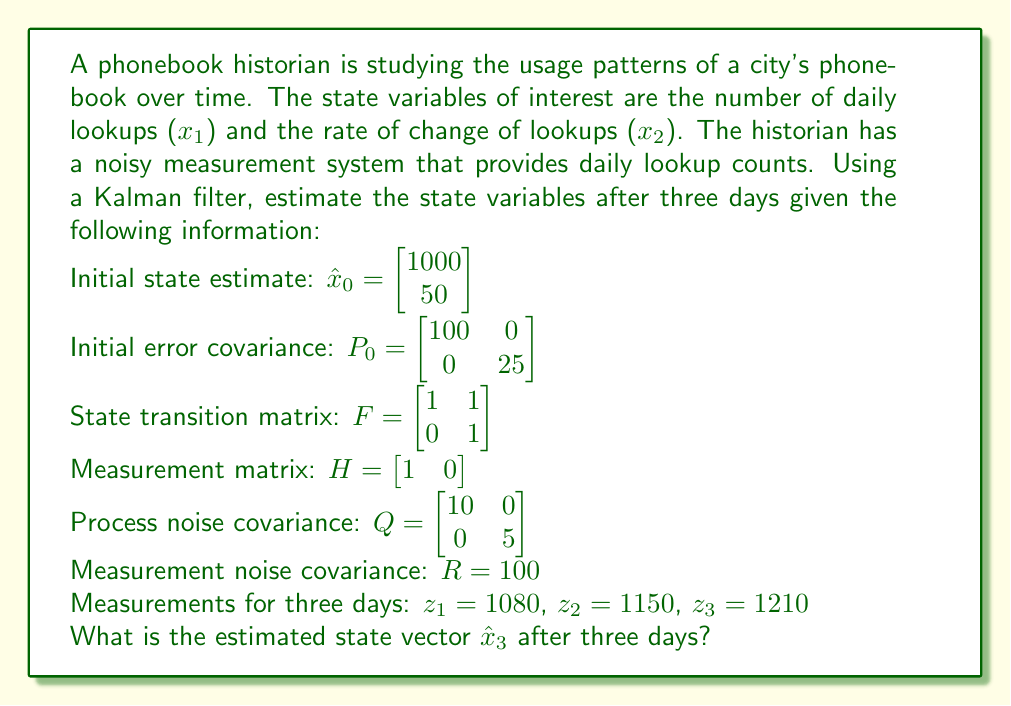Show me your answer to this math problem. To solve this problem, we need to apply the Kalman filter algorithm for three time steps. The Kalman filter consists of two main steps: prediction and update. We'll go through each day's calculations step by step.

1. Initialize:
   $\hat{x}_0 = \begin{bmatrix} 1000 \\ 50 \end{bmatrix}$
   $P_0 = \begin{bmatrix} 100 & 0 \\ 0 & 25 \end{bmatrix}$

2. Day 1:
   Predict:
   $\hat{x}_{1|0} = F\hat{x}_0 = \begin{bmatrix} 1 & 1 \\ 0 & 1 \end{bmatrix} \begin{bmatrix} 1000 \\ 50 \end{bmatrix} = \begin{bmatrix} 1050 \\ 50 \end{bmatrix}$
   $P_{1|0} = FP_0F^T + Q = \begin{bmatrix} 235 & 25 \\ 25 & 30 \end{bmatrix}$

   Update:
   $K_1 = P_{1|0}H^T(HP_{1|0}H^T + R)^{-1} = \begin{bmatrix} 0.7015 \\ 0.0746 \end{bmatrix}$
   $\hat{x}_1 = \hat{x}_{1|0} + K_1(z_1 - H\hat{x}_{1|0}) = \begin{bmatrix} 1071.0 \\ 52.24 \end{bmatrix}$
   $P_1 = (I - K_1H)P_{1|0} = \begin{bmatrix} 70.15 & 25 \\ 0 & 30 \end{bmatrix}$

3. Day 2:
   Predict:
   $\hat{x}_{2|1} = F\hat{x}_1 = \begin{bmatrix} 1123.24 \\ 52.24 \end{bmatrix}$
   $P_{2|1} = FP_1F^T + Q = \begin{bmatrix} 205.15 & 25 \\ 25 & 35 \end{bmatrix}$

   Update:
   $K_2 = P_{2|1}H^T(HP_{2|1}H^T + R)^{-1} = \begin{bmatrix} 0.6721 \\ 0.0820 \end{bmatrix}$
   $\hat{x}_2 = \hat{x}_{2|1} + K_2(z_2 - H\hat{x}_{2|1}) = \begin{bmatrix} 1141.23 \\ 54.45 \end{bmatrix}$
   $P_2 = (I - K_2H)P_{2|1} = \begin{bmatrix} 67.21 & 25 \\ 0 & 35 \end{bmatrix}$

4. Day 3:
   Predict:
   $\hat{x}_{3|2} = F\hat{x}_2 = \begin{bmatrix} 1195.68 \\ 54.45 \end{bmatrix}$
   $P_{3|2} = FP_2F^T + Q = \begin{bmatrix} 202.21 & 25 \\ 25 & 40 \end{bmatrix}$

   Update:
   $K_3 = P_{3|2}H^T(HP_{3|2}H^T + R)^{-1} = \begin{bmatrix} 0.6691 \\ 0.0833 \end{bmatrix}$
   $\hat{x}_3 = \hat{x}_{3|2} + K_3(z_3 - H\hat{x}_{3|2}) = \begin{bmatrix} 1205.62 \\ 55.70 \end{bmatrix}$
   $P_3 = (I - K_3H)P_{3|2} = \begin{bmatrix} 66.91 & 25 \\ 0 & 40 \end{bmatrix}$

The final state estimate after three days is $\hat{x}_3$.
Answer: The estimated state vector after three days is:

$$\hat{x}_3 = \begin{bmatrix} 1205.62 \\ 55.70 \end{bmatrix}$$

This means the estimated number of daily lookups is 1205.62, and the estimated rate of change of lookups is 55.70 per day. 